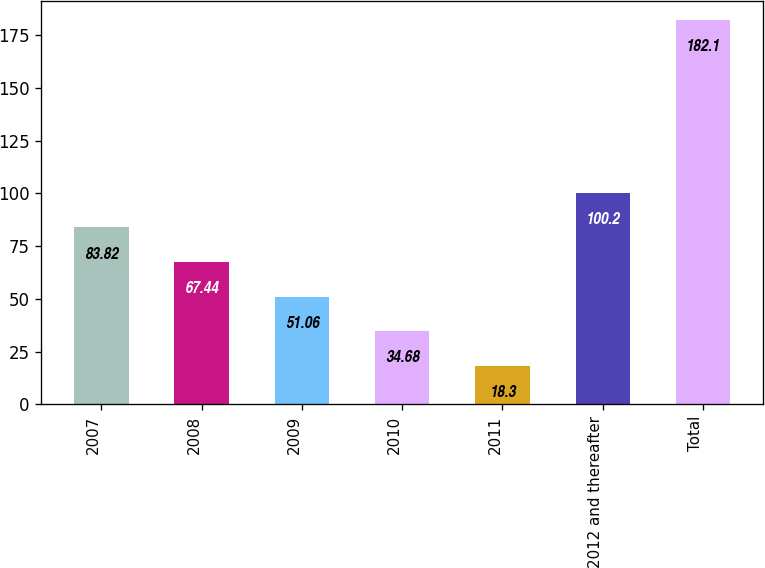<chart> <loc_0><loc_0><loc_500><loc_500><bar_chart><fcel>2007<fcel>2008<fcel>2009<fcel>2010<fcel>2011<fcel>2012 and thereafter<fcel>Total<nl><fcel>83.82<fcel>67.44<fcel>51.06<fcel>34.68<fcel>18.3<fcel>100.2<fcel>182.1<nl></chart> 